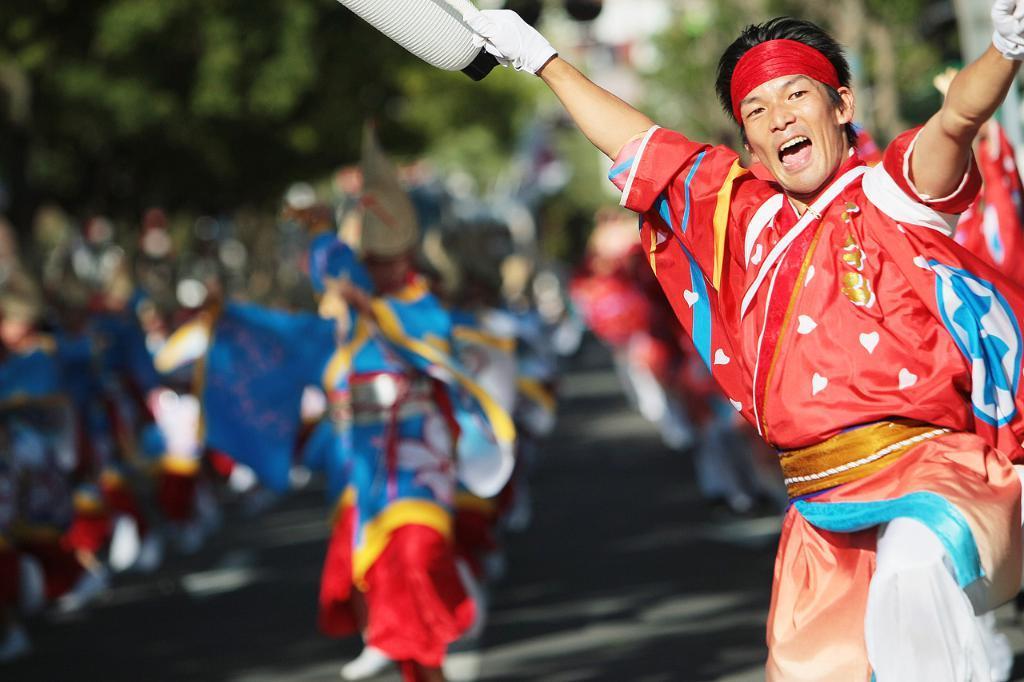Describe this image in one or two sentences. In the foreground of the picture there is a person dancing with a cheerful face and holding an object. The background is blurred. In the background there are people and greenery. 